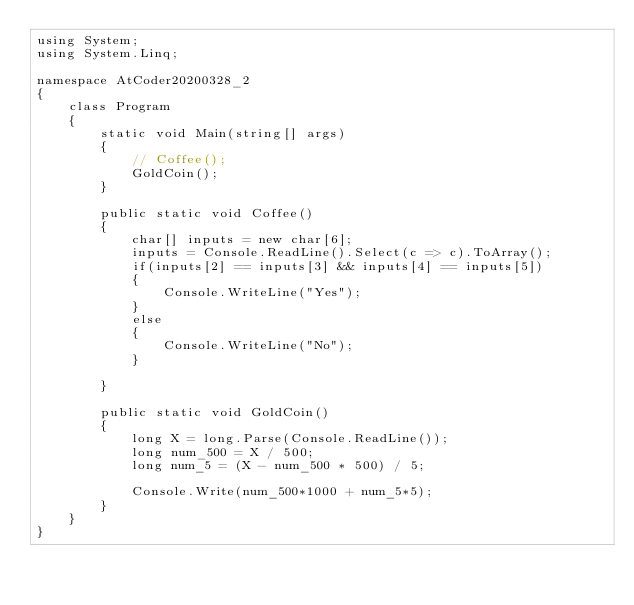Convert code to text. <code><loc_0><loc_0><loc_500><loc_500><_C#_>using System;
using System.Linq;

namespace AtCoder20200328_2
{
    class Program
    {
        static void Main(string[] args)
        {
            // Coffee();
            GoldCoin();
        }

        public static void Coffee()
        {
            char[] inputs = new char[6];
            inputs = Console.ReadLine().Select(c => c).ToArray();
            if(inputs[2] == inputs[3] && inputs[4] == inputs[5])
            {
                Console.WriteLine("Yes");
            }
            else
            {
                Console.WriteLine("No");
            }

        }

        public static void GoldCoin()
        {
            long X = long.Parse(Console.ReadLine());
            long num_500 = X / 500;
            long num_5 = (X - num_500 * 500) / 5;

            Console.Write(num_500*1000 + num_5*5);
        }
    }
}
</code> 